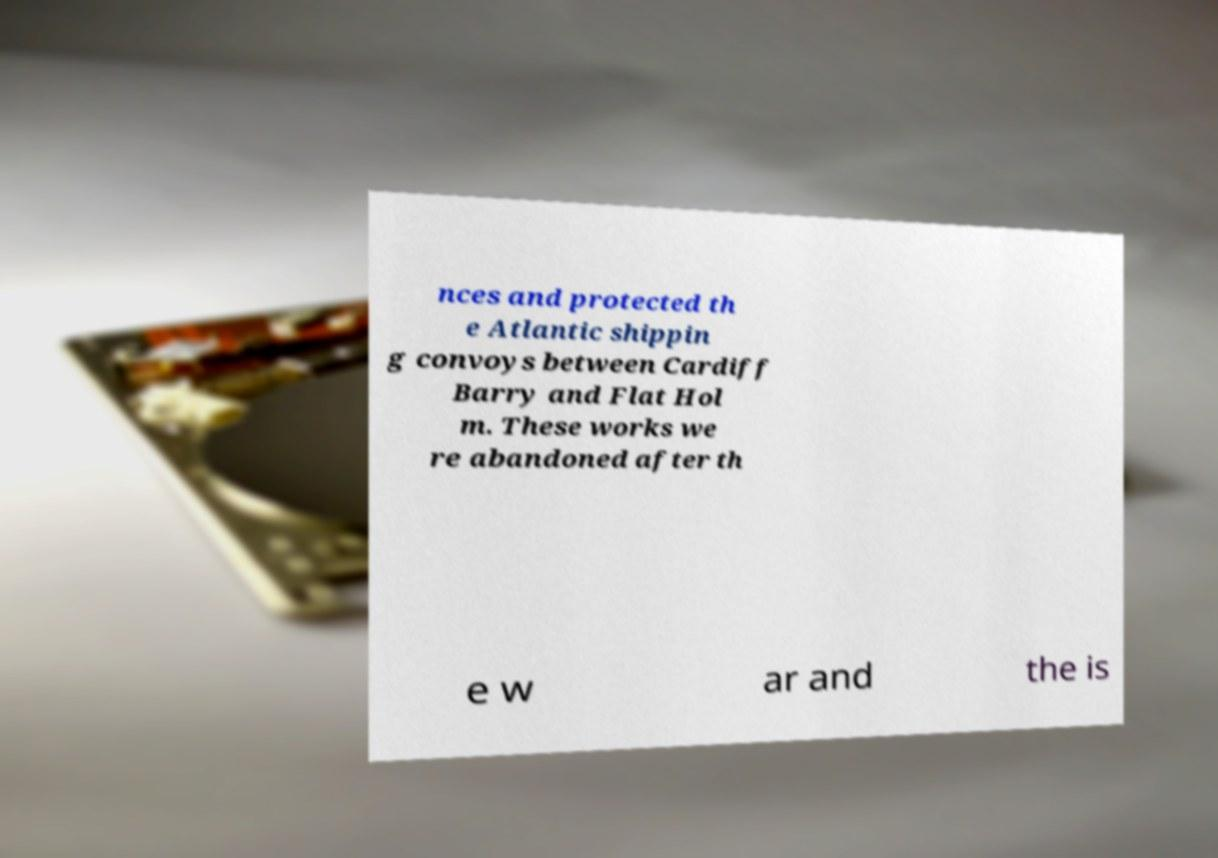What messages or text are displayed in this image? I need them in a readable, typed format. nces and protected th e Atlantic shippin g convoys between Cardiff Barry and Flat Hol m. These works we re abandoned after th e w ar and the is 